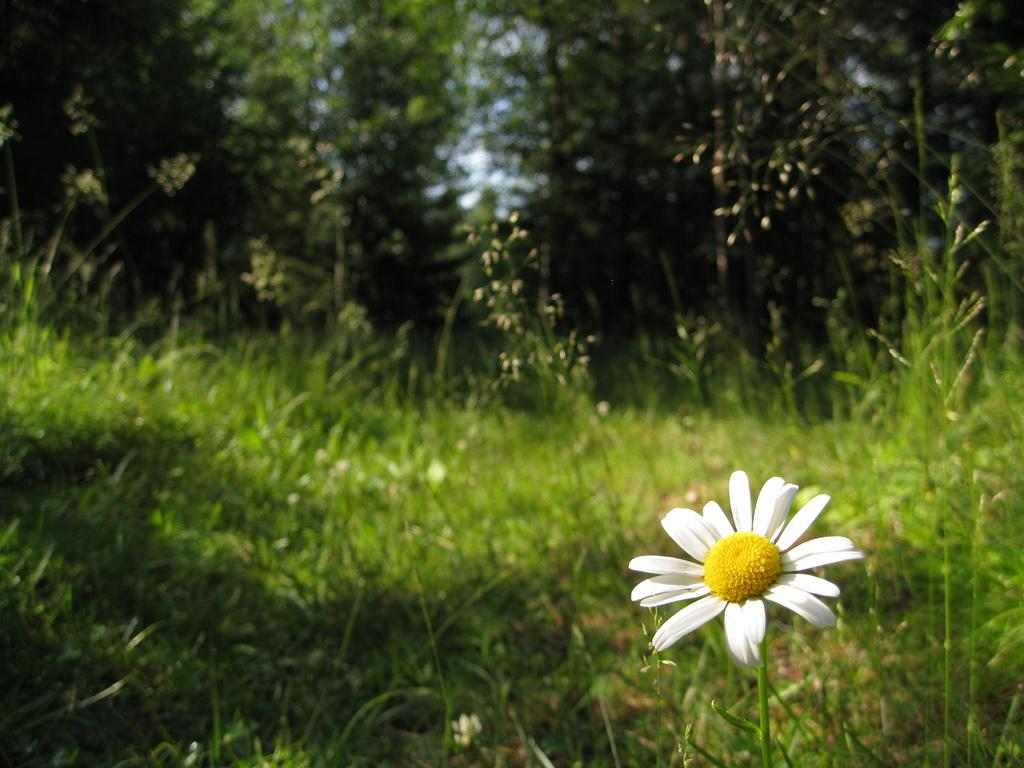What type of terrain is visible in the image? The image contains land full of grass. What can be seen in the background of the image? There are trees in the background of the image. Where is the white-colored flower located in the image? The white-colored flower is in the bottom right corner of the image. What is the belief of the steam in the image? There is no steam present in the image, so it is not possible to determine any beliefs. 